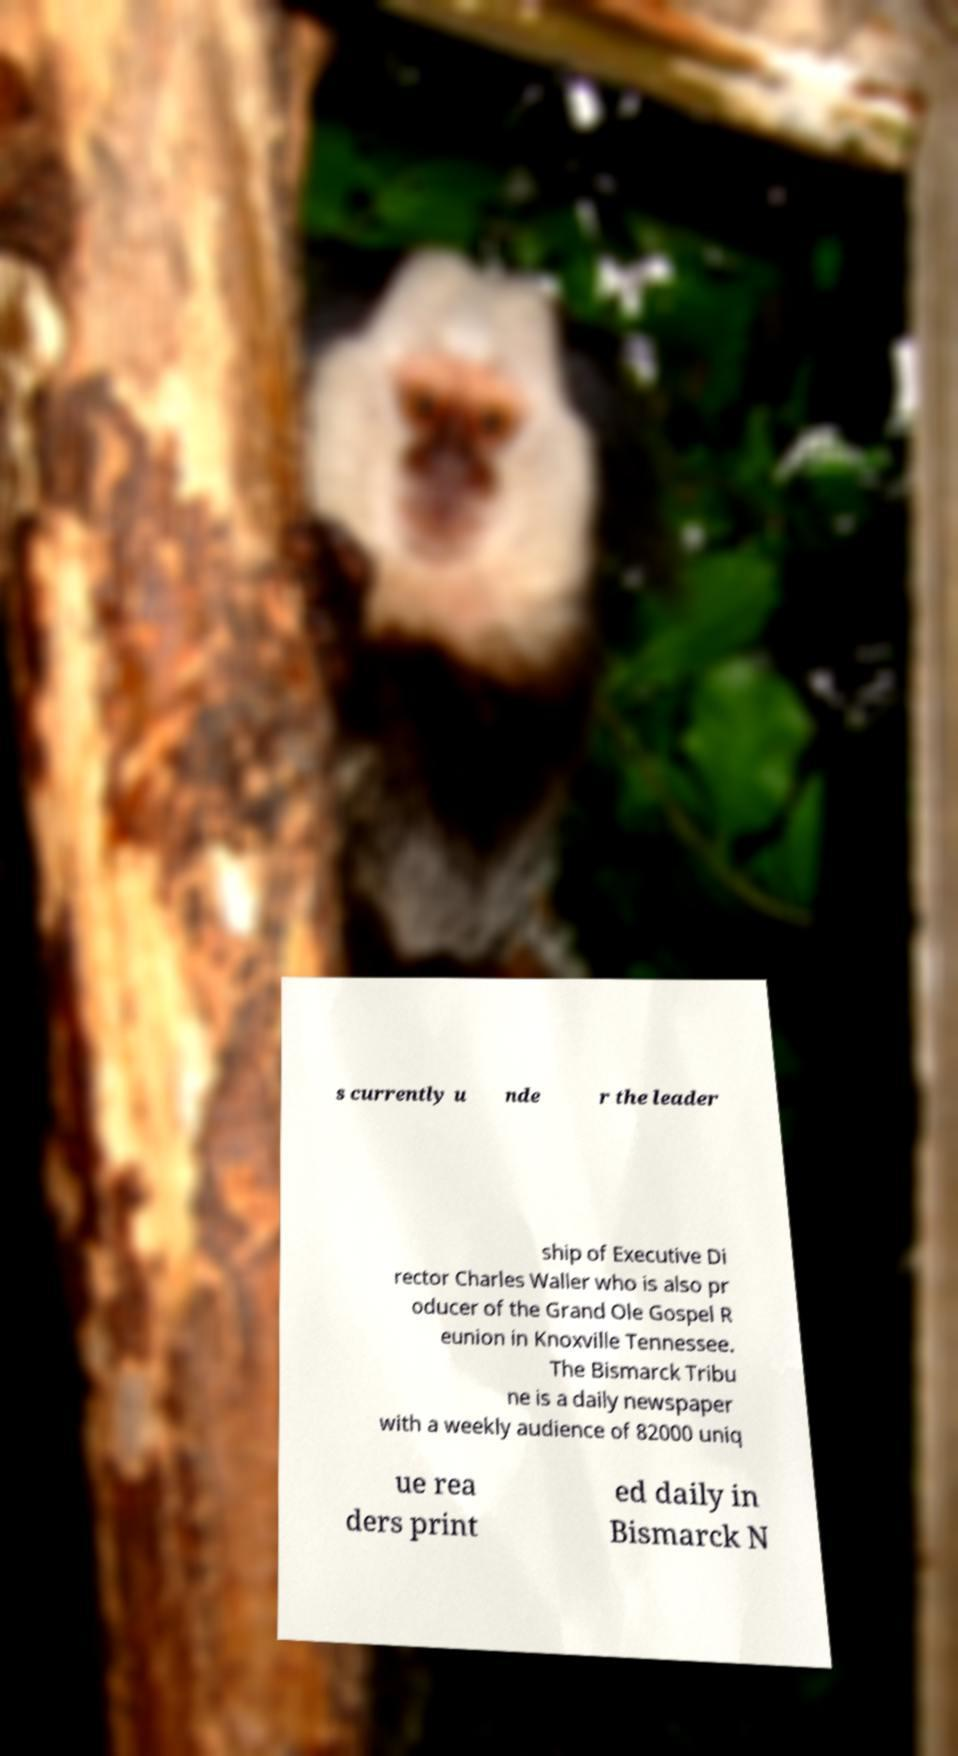Please read and relay the text visible in this image. What does it say? s currently u nde r the leader ship of Executive Di rector Charles Waller who is also pr oducer of the Grand Ole Gospel R eunion in Knoxville Tennessee. The Bismarck Tribu ne is a daily newspaper with a weekly audience of 82000 uniq ue rea ders print ed daily in Bismarck N 